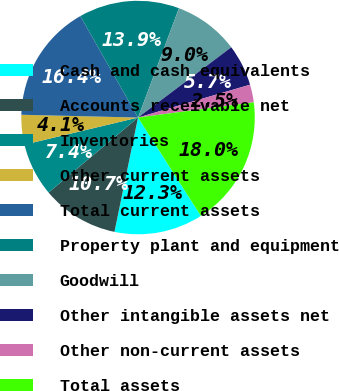<chart> <loc_0><loc_0><loc_500><loc_500><pie_chart><fcel>Cash and cash equivalents<fcel>Accounts receivable net<fcel>Inventories<fcel>Other current assets<fcel>Total current assets<fcel>Property plant and equipment<fcel>Goodwill<fcel>Other intangible assets net<fcel>Other non-current assets<fcel>Total assets<nl><fcel>12.29%<fcel>10.66%<fcel>7.38%<fcel>4.1%<fcel>16.39%<fcel>13.93%<fcel>9.02%<fcel>5.74%<fcel>2.46%<fcel>18.03%<nl></chart> 